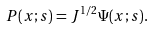Convert formula to latex. <formula><loc_0><loc_0><loc_500><loc_500>P ( x ; s ) = J ^ { 1 / 2 } \Psi ( x ; s ) .</formula> 